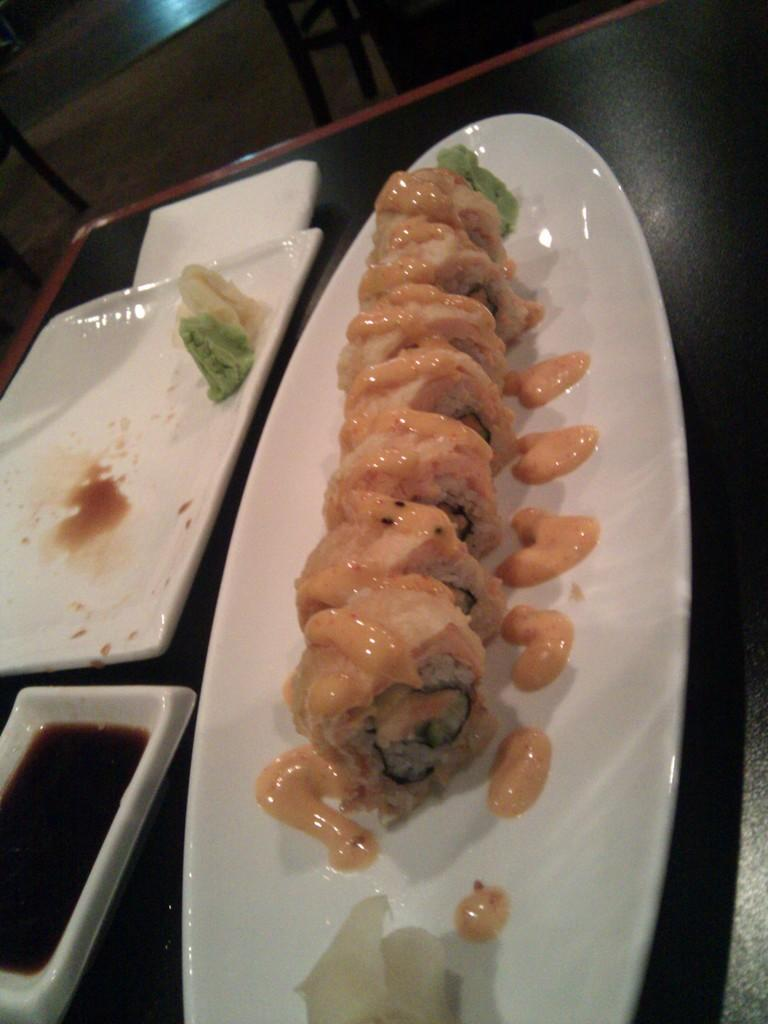What is present on the plate in the image? There are food items on the plate in the image. Where is the plate located? The plate is on a table. What type of tail can be seen on the food items in the image? There are no tails present on the food items in the image. 